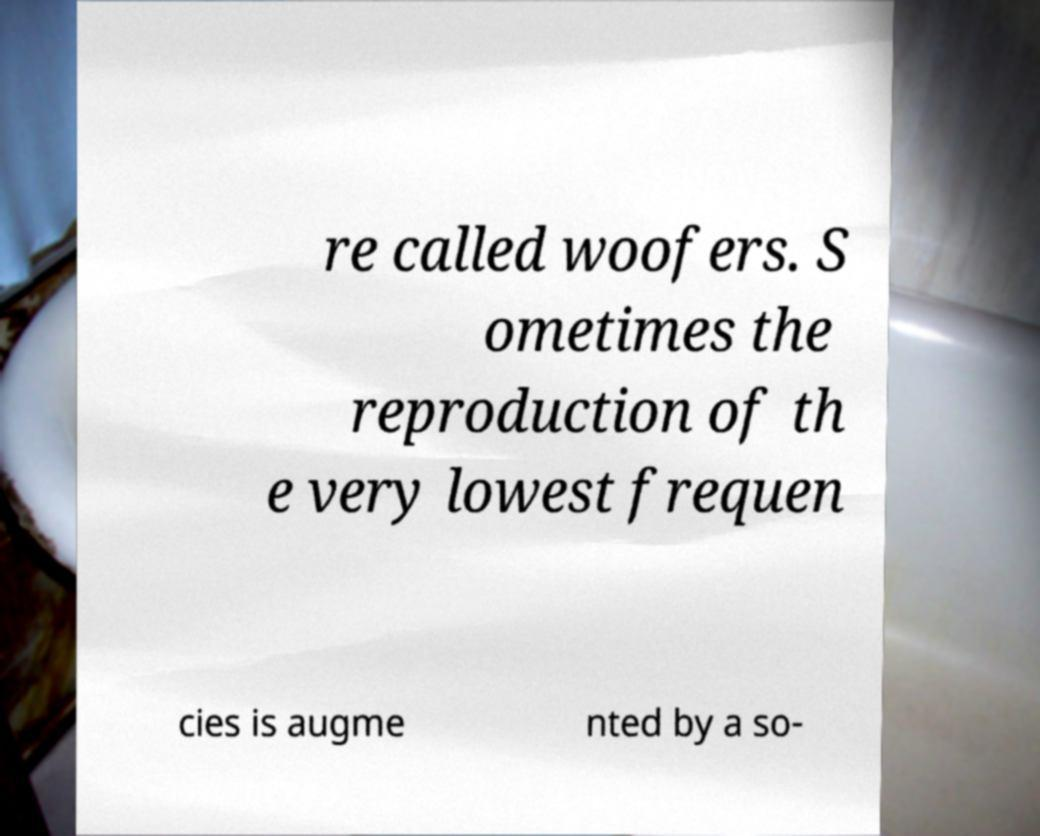Please identify and transcribe the text found in this image. re called woofers. S ometimes the reproduction of th e very lowest frequen cies is augme nted by a so- 